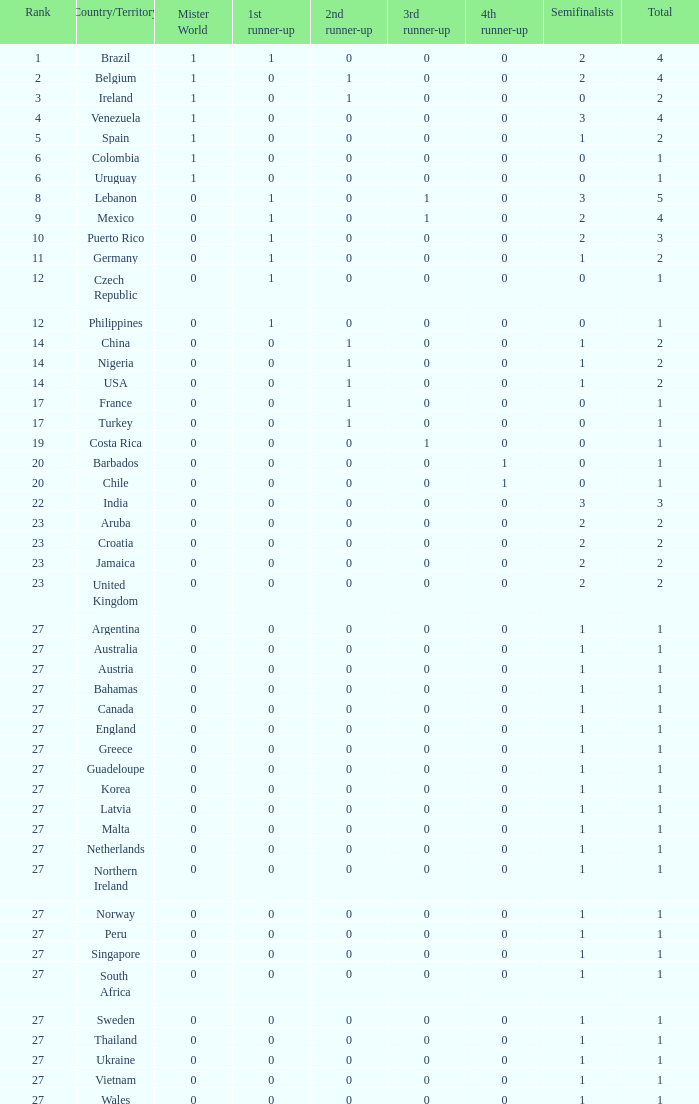How many times has turkey achieved the 3rd runner-up status? 1.0. 